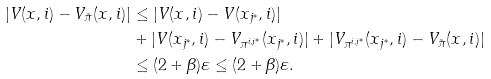Convert formula to latex. <formula><loc_0><loc_0><loc_500><loc_500>| V ( x , i ) - V _ { \tilde { \pi } } ( x , i ) | & \leq | V ( x , i ) - V ( x _ { j ^ { * } } , i ) | \\ & + | V ( x _ { j ^ { * } } , i ) - V _ { \pi ^ { i , j ^ { * } } } ( x _ { j ^ { * } } , i ) | + | V _ { \pi ^ { i , j ^ { * } } } ( x _ { j ^ { * } } , i ) - V _ { \tilde { \pi } } ( x , i ) | \\ & \leq ( 2 + \beta ) \varepsilon \leq ( 2 + \beta ) \varepsilon .</formula> 